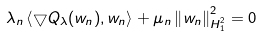Convert formula to latex. <formula><loc_0><loc_0><loc_500><loc_500>\lambda _ { n } \left \langle \bigtriangledown Q _ { \lambda } ( w _ { n } ) , w _ { n } \right \rangle + \mu _ { n } \left \| w _ { n } \right \| _ { H _ { 1 } ^ { 2 } } ^ { 2 } = 0</formula> 